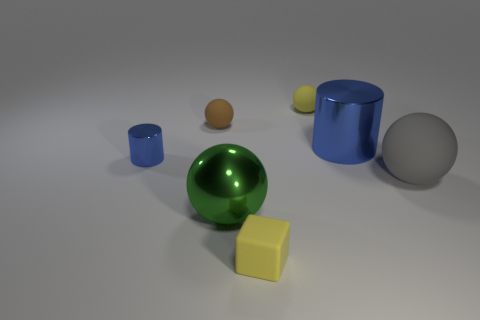Subtract all gray balls. How many balls are left? 3 Subtract all yellow spheres. How many spheres are left? 3 Add 1 big yellow metal cylinders. How many objects exist? 8 Subtract all cylinders. How many objects are left? 5 Subtract all purple spheres. Subtract all green cylinders. How many spheres are left? 4 Add 7 tiny purple metal cylinders. How many tiny purple metal cylinders exist? 7 Subtract 0 blue cubes. How many objects are left? 7 Subtract all tiny balls. Subtract all tiny blue things. How many objects are left? 4 Add 5 tiny metal things. How many tiny metal things are left? 6 